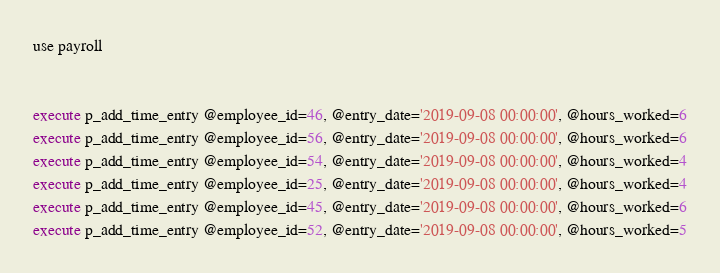Convert code to text. <code><loc_0><loc_0><loc_500><loc_500><_SQL_>use payroll


execute p_add_time_entry @employee_id=46, @entry_date='2019-09-08 00:00:00', @hours_worked=6
execute p_add_time_entry @employee_id=56, @entry_date='2019-09-08 00:00:00', @hours_worked=6
execute p_add_time_entry @employee_id=54, @entry_date='2019-09-08 00:00:00', @hours_worked=4
execute p_add_time_entry @employee_id=25, @entry_date='2019-09-08 00:00:00', @hours_worked=4
execute p_add_time_entry @employee_id=45, @entry_date='2019-09-08 00:00:00', @hours_worked=6
execute p_add_time_entry @employee_id=52, @entry_date='2019-09-08 00:00:00', @hours_worked=5

</code> 